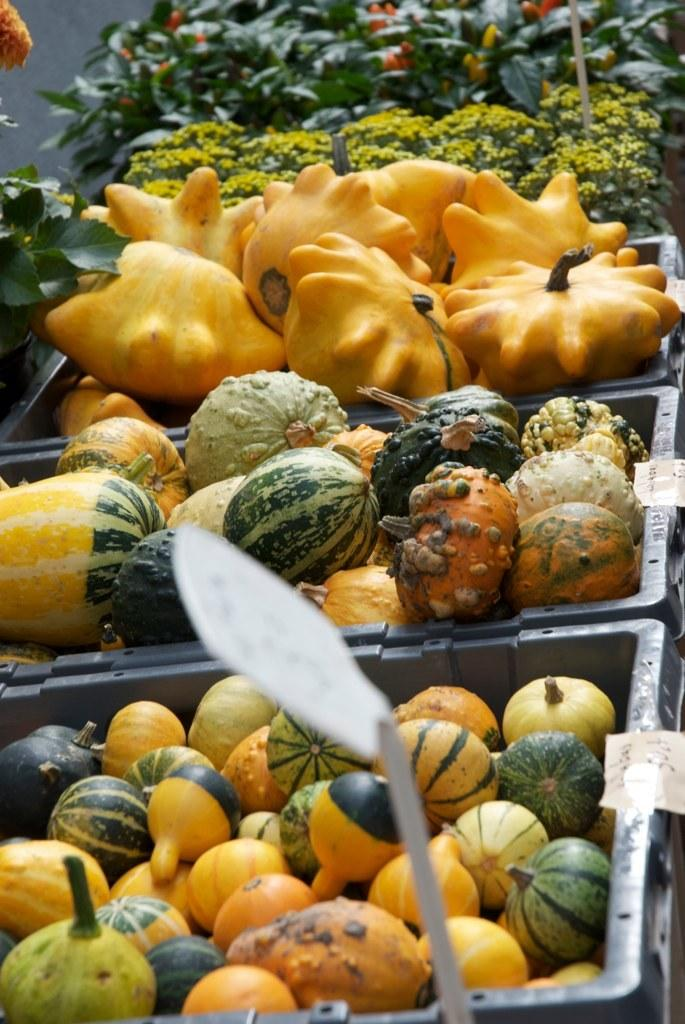What types of fruits and vegetables are present in the image? There are watermelons, pumpkins, and broccoli in the image. How are the fruits and vegetables arranged in the image? The vegetables are in baskets, while the watermelons and pumpkins are not in baskets. What can be seen in the background of the image? There are plants visible in the background of the image. What discovery did the farmer make while tending to the plants in the image? There is no farmer present in the image, and no discovery is mentioned or depicted. 